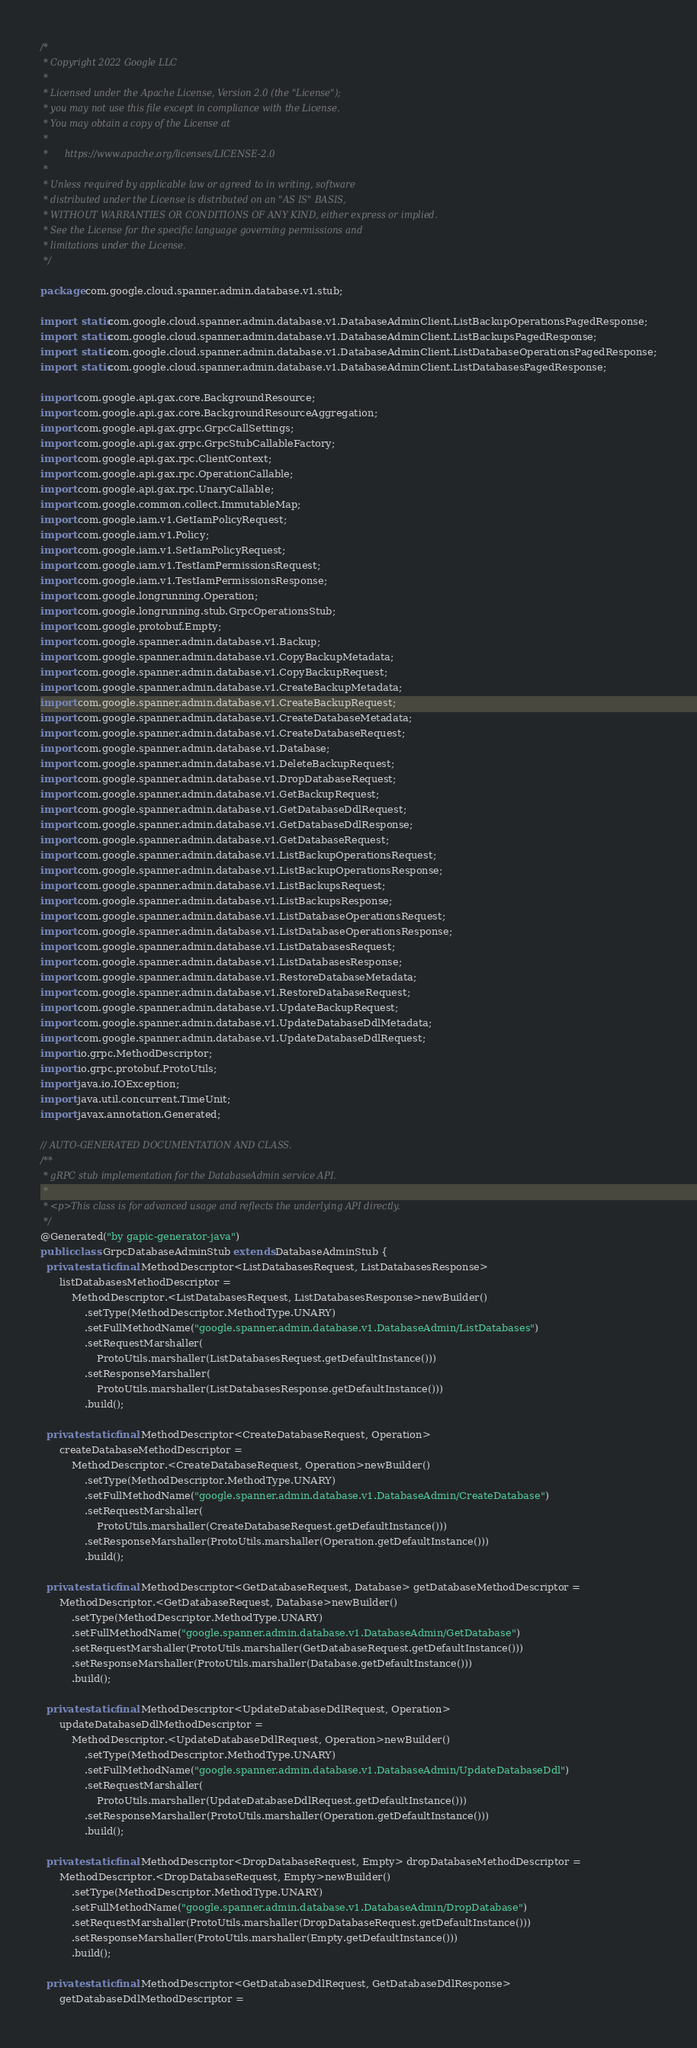<code> <loc_0><loc_0><loc_500><loc_500><_Java_>/*
 * Copyright 2022 Google LLC
 *
 * Licensed under the Apache License, Version 2.0 (the "License");
 * you may not use this file except in compliance with the License.
 * You may obtain a copy of the License at
 *
 *      https://www.apache.org/licenses/LICENSE-2.0
 *
 * Unless required by applicable law or agreed to in writing, software
 * distributed under the License is distributed on an "AS IS" BASIS,
 * WITHOUT WARRANTIES OR CONDITIONS OF ANY KIND, either express or implied.
 * See the License for the specific language governing permissions and
 * limitations under the License.
 */

package com.google.cloud.spanner.admin.database.v1.stub;

import static com.google.cloud.spanner.admin.database.v1.DatabaseAdminClient.ListBackupOperationsPagedResponse;
import static com.google.cloud.spanner.admin.database.v1.DatabaseAdminClient.ListBackupsPagedResponse;
import static com.google.cloud.spanner.admin.database.v1.DatabaseAdminClient.ListDatabaseOperationsPagedResponse;
import static com.google.cloud.spanner.admin.database.v1.DatabaseAdminClient.ListDatabasesPagedResponse;

import com.google.api.gax.core.BackgroundResource;
import com.google.api.gax.core.BackgroundResourceAggregation;
import com.google.api.gax.grpc.GrpcCallSettings;
import com.google.api.gax.grpc.GrpcStubCallableFactory;
import com.google.api.gax.rpc.ClientContext;
import com.google.api.gax.rpc.OperationCallable;
import com.google.api.gax.rpc.UnaryCallable;
import com.google.common.collect.ImmutableMap;
import com.google.iam.v1.GetIamPolicyRequest;
import com.google.iam.v1.Policy;
import com.google.iam.v1.SetIamPolicyRequest;
import com.google.iam.v1.TestIamPermissionsRequest;
import com.google.iam.v1.TestIamPermissionsResponse;
import com.google.longrunning.Operation;
import com.google.longrunning.stub.GrpcOperationsStub;
import com.google.protobuf.Empty;
import com.google.spanner.admin.database.v1.Backup;
import com.google.spanner.admin.database.v1.CopyBackupMetadata;
import com.google.spanner.admin.database.v1.CopyBackupRequest;
import com.google.spanner.admin.database.v1.CreateBackupMetadata;
import com.google.spanner.admin.database.v1.CreateBackupRequest;
import com.google.spanner.admin.database.v1.CreateDatabaseMetadata;
import com.google.spanner.admin.database.v1.CreateDatabaseRequest;
import com.google.spanner.admin.database.v1.Database;
import com.google.spanner.admin.database.v1.DeleteBackupRequest;
import com.google.spanner.admin.database.v1.DropDatabaseRequest;
import com.google.spanner.admin.database.v1.GetBackupRequest;
import com.google.spanner.admin.database.v1.GetDatabaseDdlRequest;
import com.google.spanner.admin.database.v1.GetDatabaseDdlResponse;
import com.google.spanner.admin.database.v1.GetDatabaseRequest;
import com.google.spanner.admin.database.v1.ListBackupOperationsRequest;
import com.google.spanner.admin.database.v1.ListBackupOperationsResponse;
import com.google.spanner.admin.database.v1.ListBackupsRequest;
import com.google.spanner.admin.database.v1.ListBackupsResponse;
import com.google.spanner.admin.database.v1.ListDatabaseOperationsRequest;
import com.google.spanner.admin.database.v1.ListDatabaseOperationsResponse;
import com.google.spanner.admin.database.v1.ListDatabasesRequest;
import com.google.spanner.admin.database.v1.ListDatabasesResponse;
import com.google.spanner.admin.database.v1.RestoreDatabaseMetadata;
import com.google.spanner.admin.database.v1.RestoreDatabaseRequest;
import com.google.spanner.admin.database.v1.UpdateBackupRequest;
import com.google.spanner.admin.database.v1.UpdateDatabaseDdlMetadata;
import com.google.spanner.admin.database.v1.UpdateDatabaseDdlRequest;
import io.grpc.MethodDescriptor;
import io.grpc.protobuf.ProtoUtils;
import java.io.IOException;
import java.util.concurrent.TimeUnit;
import javax.annotation.Generated;

// AUTO-GENERATED DOCUMENTATION AND CLASS.
/**
 * gRPC stub implementation for the DatabaseAdmin service API.
 *
 * <p>This class is for advanced usage and reflects the underlying API directly.
 */
@Generated("by gapic-generator-java")
public class GrpcDatabaseAdminStub extends DatabaseAdminStub {
  private static final MethodDescriptor<ListDatabasesRequest, ListDatabasesResponse>
      listDatabasesMethodDescriptor =
          MethodDescriptor.<ListDatabasesRequest, ListDatabasesResponse>newBuilder()
              .setType(MethodDescriptor.MethodType.UNARY)
              .setFullMethodName("google.spanner.admin.database.v1.DatabaseAdmin/ListDatabases")
              .setRequestMarshaller(
                  ProtoUtils.marshaller(ListDatabasesRequest.getDefaultInstance()))
              .setResponseMarshaller(
                  ProtoUtils.marshaller(ListDatabasesResponse.getDefaultInstance()))
              .build();

  private static final MethodDescriptor<CreateDatabaseRequest, Operation>
      createDatabaseMethodDescriptor =
          MethodDescriptor.<CreateDatabaseRequest, Operation>newBuilder()
              .setType(MethodDescriptor.MethodType.UNARY)
              .setFullMethodName("google.spanner.admin.database.v1.DatabaseAdmin/CreateDatabase")
              .setRequestMarshaller(
                  ProtoUtils.marshaller(CreateDatabaseRequest.getDefaultInstance()))
              .setResponseMarshaller(ProtoUtils.marshaller(Operation.getDefaultInstance()))
              .build();

  private static final MethodDescriptor<GetDatabaseRequest, Database> getDatabaseMethodDescriptor =
      MethodDescriptor.<GetDatabaseRequest, Database>newBuilder()
          .setType(MethodDescriptor.MethodType.UNARY)
          .setFullMethodName("google.spanner.admin.database.v1.DatabaseAdmin/GetDatabase")
          .setRequestMarshaller(ProtoUtils.marshaller(GetDatabaseRequest.getDefaultInstance()))
          .setResponseMarshaller(ProtoUtils.marshaller(Database.getDefaultInstance()))
          .build();

  private static final MethodDescriptor<UpdateDatabaseDdlRequest, Operation>
      updateDatabaseDdlMethodDescriptor =
          MethodDescriptor.<UpdateDatabaseDdlRequest, Operation>newBuilder()
              .setType(MethodDescriptor.MethodType.UNARY)
              .setFullMethodName("google.spanner.admin.database.v1.DatabaseAdmin/UpdateDatabaseDdl")
              .setRequestMarshaller(
                  ProtoUtils.marshaller(UpdateDatabaseDdlRequest.getDefaultInstance()))
              .setResponseMarshaller(ProtoUtils.marshaller(Operation.getDefaultInstance()))
              .build();

  private static final MethodDescriptor<DropDatabaseRequest, Empty> dropDatabaseMethodDescriptor =
      MethodDescriptor.<DropDatabaseRequest, Empty>newBuilder()
          .setType(MethodDescriptor.MethodType.UNARY)
          .setFullMethodName("google.spanner.admin.database.v1.DatabaseAdmin/DropDatabase")
          .setRequestMarshaller(ProtoUtils.marshaller(DropDatabaseRequest.getDefaultInstance()))
          .setResponseMarshaller(ProtoUtils.marshaller(Empty.getDefaultInstance()))
          .build();

  private static final MethodDescriptor<GetDatabaseDdlRequest, GetDatabaseDdlResponse>
      getDatabaseDdlMethodDescriptor =</code> 